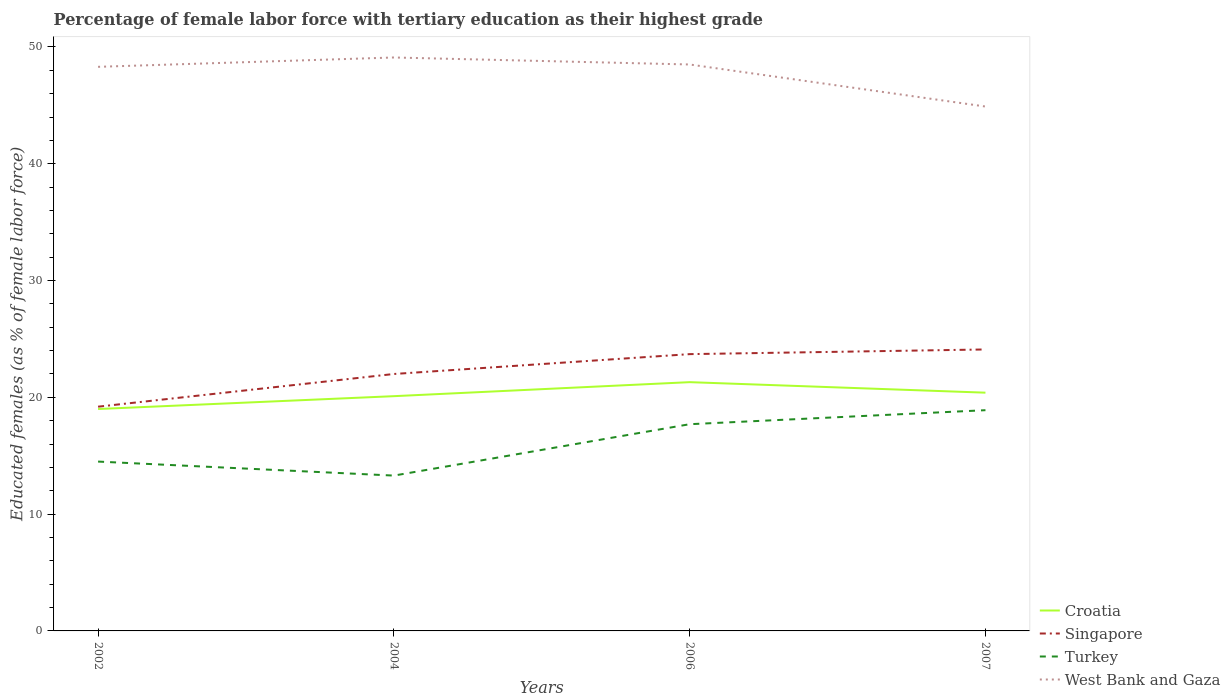Across all years, what is the maximum percentage of female labor force with tertiary education in Singapore?
Give a very brief answer. 19.2. What is the total percentage of female labor force with tertiary education in Croatia in the graph?
Offer a terse response. 0.9. What is the difference between the highest and the second highest percentage of female labor force with tertiary education in Turkey?
Offer a terse response. 5.6. What is the difference between the highest and the lowest percentage of female labor force with tertiary education in Turkey?
Provide a short and direct response. 2. Is the percentage of female labor force with tertiary education in Singapore strictly greater than the percentage of female labor force with tertiary education in West Bank and Gaza over the years?
Your response must be concise. Yes. How many lines are there?
Ensure brevity in your answer.  4. How many years are there in the graph?
Provide a succinct answer. 4. What is the difference between two consecutive major ticks on the Y-axis?
Your answer should be compact. 10. Are the values on the major ticks of Y-axis written in scientific E-notation?
Keep it short and to the point. No. Does the graph contain grids?
Offer a terse response. No. Where does the legend appear in the graph?
Keep it short and to the point. Bottom right. How many legend labels are there?
Ensure brevity in your answer.  4. How are the legend labels stacked?
Offer a very short reply. Vertical. What is the title of the graph?
Ensure brevity in your answer.  Percentage of female labor force with tertiary education as their highest grade. What is the label or title of the Y-axis?
Provide a short and direct response. Educated females (as % of female labor force). What is the Educated females (as % of female labor force) in Croatia in 2002?
Offer a terse response. 19. What is the Educated females (as % of female labor force) in Singapore in 2002?
Your answer should be very brief. 19.2. What is the Educated females (as % of female labor force) in Turkey in 2002?
Offer a terse response. 14.5. What is the Educated females (as % of female labor force) in West Bank and Gaza in 2002?
Your response must be concise. 48.3. What is the Educated females (as % of female labor force) in Croatia in 2004?
Keep it short and to the point. 20.1. What is the Educated females (as % of female labor force) of Turkey in 2004?
Make the answer very short. 13.3. What is the Educated females (as % of female labor force) in West Bank and Gaza in 2004?
Ensure brevity in your answer.  49.1. What is the Educated females (as % of female labor force) in Croatia in 2006?
Keep it short and to the point. 21.3. What is the Educated females (as % of female labor force) of Singapore in 2006?
Keep it short and to the point. 23.7. What is the Educated females (as % of female labor force) in Turkey in 2006?
Offer a terse response. 17.7. What is the Educated females (as % of female labor force) of West Bank and Gaza in 2006?
Provide a succinct answer. 48.5. What is the Educated females (as % of female labor force) of Croatia in 2007?
Provide a short and direct response. 20.4. What is the Educated females (as % of female labor force) in Singapore in 2007?
Offer a terse response. 24.1. What is the Educated females (as % of female labor force) of Turkey in 2007?
Offer a terse response. 18.9. What is the Educated females (as % of female labor force) in West Bank and Gaza in 2007?
Ensure brevity in your answer.  44.9. Across all years, what is the maximum Educated females (as % of female labor force) in Croatia?
Give a very brief answer. 21.3. Across all years, what is the maximum Educated females (as % of female labor force) of Singapore?
Make the answer very short. 24.1. Across all years, what is the maximum Educated females (as % of female labor force) of Turkey?
Make the answer very short. 18.9. Across all years, what is the maximum Educated females (as % of female labor force) of West Bank and Gaza?
Your response must be concise. 49.1. Across all years, what is the minimum Educated females (as % of female labor force) of Singapore?
Make the answer very short. 19.2. Across all years, what is the minimum Educated females (as % of female labor force) in Turkey?
Make the answer very short. 13.3. Across all years, what is the minimum Educated females (as % of female labor force) in West Bank and Gaza?
Keep it short and to the point. 44.9. What is the total Educated females (as % of female labor force) in Croatia in the graph?
Make the answer very short. 80.8. What is the total Educated females (as % of female labor force) of Singapore in the graph?
Give a very brief answer. 89. What is the total Educated females (as % of female labor force) in Turkey in the graph?
Provide a succinct answer. 64.4. What is the total Educated females (as % of female labor force) of West Bank and Gaza in the graph?
Your answer should be very brief. 190.8. What is the difference between the Educated females (as % of female labor force) in Singapore in 2002 and that in 2004?
Your answer should be very brief. -2.8. What is the difference between the Educated females (as % of female labor force) in West Bank and Gaza in 2002 and that in 2004?
Ensure brevity in your answer.  -0.8. What is the difference between the Educated females (as % of female labor force) of Croatia in 2002 and that in 2006?
Provide a succinct answer. -2.3. What is the difference between the Educated females (as % of female labor force) in Singapore in 2002 and that in 2006?
Your answer should be very brief. -4.5. What is the difference between the Educated females (as % of female labor force) of Turkey in 2002 and that in 2006?
Ensure brevity in your answer.  -3.2. What is the difference between the Educated females (as % of female labor force) of Singapore in 2002 and that in 2007?
Ensure brevity in your answer.  -4.9. What is the difference between the Educated females (as % of female labor force) of West Bank and Gaza in 2002 and that in 2007?
Offer a very short reply. 3.4. What is the difference between the Educated females (as % of female labor force) of Croatia in 2004 and that in 2006?
Your response must be concise. -1.2. What is the difference between the Educated females (as % of female labor force) in Singapore in 2004 and that in 2006?
Your answer should be compact. -1.7. What is the difference between the Educated females (as % of female labor force) in Turkey in 2004 and that in 2006?
Offer a terse response. -4.4. What is the difference between the Educated females (as % of female labor force) of West Bank and Gaza in 2004 and that in 2006?
Your answer should be very brief. 0.6. What is the difference between the Educated females (as % of female labor force) in Turkey in 2004 and that in 2007?
Your response must be concise. -5.6. What is the difference between the Educated females (as % of female labor force) in Turkey in 2006 and that in 2007?
Offer a terse response. -1.2. What is the difference between the Educated females (as % of female labor force) in Croatia in 2002 and the Educated females (as % of female labor force) in Singapore in 2004?
Give a very brief answer. -3. What is the difference between the Educated females (as % of female labor force) in Croatia in 2002 and the Educated females (as % of female labor force) in West Bank and Gaza in 2004?
Offer a very short reply. -30.1. What is the difference between the Educated females (as % of female labor force) of Singapore in 2002 and the Educated females (as % of female labor force) of Turkey in 2004?
Keep it short and to the point. 5.9. What is the difference between the Educated females (as % of female labor force) in Singapore in 2002 and the Educated females (as % of female labor force) in West Bank and Gaza in 2004?
Provide a short and direct response. -29.9. What is the difference between the Educated females (as % of female labor force) of Turkey in 2002 and the Educated females (as % of female labor force) of West Bank and Gaza in 2004?
Offer a terse response. -34.6. What is the difference between the Educated females (as % of female labor force) of Croatia in 2002 and the Educated females (as % of female labor force) of Singapore in 2006?
Give a very brief answer. -4.7. What is the difference between the Educated females (as % of female labor force) of Croatia in 2002 and the Educated females (as % of female labor force) of West Bank and Gaza in 2006?
Provide a short and direct response. -29.5. What is the difference between the Educated females (as % of female labor force) of Singapore in 2002 and the Educated females (as % of female labor force) of West Bank and Gaza in 2006?
Keep it short and to the point. -29.3. What is the difference between the Educated females (as % of female labor force) in Turkey in 2002 and the Educated females (as % of female labor force) in West Bank and Gaza in 2006?
Ensure brevity in your answer.  -34. What is the difference between the Educated females (as % of female labor force) in Croatia in 2002 and the Educated females (as % of female labor force) in Singapore in 2007?
Make the answer very short. -5.1. What is the difference between the Educated females (as % of female labor force) of Croatia in 2002 and the Educated females (as % of female labor force) of West Bank and Gaza in 2007?
Give a very brief answer. -25.9. What is the difference between the Educated females (as % of female labor force) of Singapore in 2002 and the Educated females (as % of female labor force) of West Bank and Gaza in 2007?
Ensure brevity in your answer.  -25.7. What is the difference between the Educated females (as % of female labor force) of Turkey in 2002 and the Educated females (as % of female labor force) of West Bank and Gaza in 2007?
Your answer should be very brief. -30.4. What is the difference between the Educated females (as % of female labor force) of Croatia in 2004 and the Educated females (as % of female labor force) of Singapore in 2006?
Your response must be concise. -3.6. What is the difference between the Educated females (as % of female labor force) in Croatia in 2004 and the Educated females (as % of female labor force) in Turkey in 2006?
Offer a terse response. 2.4. What is the difference between the Educated females (as % of female labor force) in Croatia in 2004 and the Educated females (as % of female labor force) in West Bank and Gaza in 2006?
Give a very brief answer. -28.4. What is the difference between the Educated females (as % of female labor force) of Singapore in 2004 and the Educated females (as % of female labor force) of West Bank and Gaza in 2006?
Provide a succinct answer. -26.5. What is the difference between the Educated females (as % of female labor force) of Turkey in 2004 and the Educated females (as % of female labor force) of West Bank and Gaza in 2006?
Offer a very short reply. -35.2. What is the difference between the Educated females (as % of female labor force) of Croatia in 2004 and the Educated females (as % of female labor force) of West Bank and Gaza in 2007?
Keep it short and to the point. -24.8. What is the difference between the Educated females (as % of female labor force) of Singapore in 2004 and the Educated females (as % of female labor force) of Turkey in 2007?
Make the answer very short. 3.1. What is the difference between the Educated females (as % of female labor force) in Singapore in 2004 and the Educated females (as % of female labor force) in West Bank and Gaza in 2007?
Ensure brevity in your answer.  -22.9. What is the difference between the Educated females (as % of female labor force) in Turkey in 2004 and the Educated females (as % of female labor force) in West Bank and Gaza in 2007?
Your answer should be compact. -31.6. What is the difference between the Educated females (as % of female labor force) in Croatia in 2006 and the Educated females (as % of female labor force) in West Bank and Gaza in 2007?
Make the answer very short. -23.6. What is the difference between the Educated females (as % of female labor force) in Singapore in 2006 and the Educated females (as % of female labor force) in Turkey in 2007?
Provide a short and direct response. 4.8. What is the difference between the Educated females (as % of female labor force) of Singapore in 2006 and the Educated females (as % of female labor force) of West Bank and Gaza in 2007?
Your answer should be compact. -21.2. What is the difference between the Educated females (as % of female labor force) in Turkey in 2006 and the Educated females (as % of female labor force) in West Bank and Gaza in 2007?
Keep it short and to the point. -27.2. What is the average Educated females (as % of female labor force) in Croatia per year?
Provide a succinct answer. 20.2. What is the average Educated females (as % of female labor force) in Singapore per year?
Make the answer very short. 22.25. What is the average Educated females (as % of female labor force) of West Bank and Gaza per year?
Offer a very short reply. 47.7. In the year 2002, what is the difference between the Educated females (as % of female labor force) in Croatia and Educated females (as % of female labor force) in Singapore?
Ensure brevity in your answer.  -0.2. In the year 2002, what is the difference between the Educated females (as % of female labor force) in Croatia and Educated females (as % of female labor force) in Turkey?
Give a very brief answer. 4.5. In the year 2002, what is the difference between the Educated females (as % of female labor force) in Croatia and Educated females (as % of female labor force) in West Bank and Gaza?
Your answer should be very brief. -29.3. In the year 2002, what is the difference between the Educated females (as % of female labor force) in Singapore and Educated females (as % of female labor force) in Turkey?
Your answer should be very brief. 4.7. In the year 2002, what is the difference between the Educated females (as % of female labor force) in Singapore and Educated females (as % of female labor force) in West Bank and Gaza?
Make the answer very short. -29.1. In the year 2002, what is the difference between the Educated females (as % of female labor force) in Turkey and Educated females (as % of female labor force) in West Bank and Gaza?
Provide a short and direct response. -33.8. In the year 2004, what is the difference between the Educated females (as % of female labor force) of Croatia and Educated females (as % of female labor force) of Singapore?
Keep it short and to the point. -1.9. In the year 2004, what is the difference between the Educated females (as % of female labor force) of Singapore and Educated females (as % of female labor force) of Turkey?
Provide a short and direct response. 8.7. In the year 2004, what is the difference between the Educated females (as % of female labor force) of Singapore and Educated females (as % of female labor force) of West Bank and Gaza?
Offer a terse response. -27.1. In the year 2004, what is the difference between the Educated females (as % of female labor force) in Turkey and Educated females (as % of female labor force) in West Bank and Gaza?
Give a very brief answer. -35.8. In the year 2006, what is the difference between the Educated females (as % of female labor force) of Croatia and Educated females (as % of female labor force) of Turkey?
Your answer should be compact. 3.6. In the year 2006, what is the difference between the Educated females (as % of female labor force) in Croatia and Educated females (as % of female labor force) in West Bank and Gaza?
Provide a succinct answer. -27.2. In the year 2006, what is the difference between the Educated females (as % of female labor force) in Singapore and Educated females (as % of female labor force) in Turkey?
Provide a succinct answer. 6. In the year 2006, what is the difference between the Educated females (as % of female labor force) in Singapore and Educated females (as % of female labor force) in West Bank and Gaza?
Ensure brevity in your answer.  -24.8. In the year 2006, what is the difference between the Educated females (as % of female labor force) of Turkey and Educated females (as % of female labor force) of West Bank and Gaza?
Offer a terse response. -30.8. In the year 2007, what is the difference between the Educated females (as % of female labor force) of Croatia and Educated females (as % of female labor force) of Singapore?
Make the answer very short. -3.7. In the year 2007, what is the difference between the Educated females (as % of female labor force) in Croatia and Educated females (as % of female labor force) in West Bank and Gaza?
Provide a succinct answer. -24.5. In the year 2007, what is the difference between the Educated females (as % of female labor force) in Singapore and Educated females (as % of female labor force) in Turkey?
Your answer should be very brief. 5.2. In the year 2007, what is the difference between the Educated females (as % of female labor force) of Singapore and Educated females (as % of female labor force) of West Bank and Gaza?
Provide a short and direct response. -20.8. In the year 2007, what is the difference between the Educated females (as % of female labor force) of Turkey and Educated females (as % of female labor force) of West Bank and Gaza?
Your answer should be very brief. -26. What is the ratio of the Educated females (as % of female labor force) in Croatia in 2002 to that in 2004?
Your response must be concise. 0.95. What is the ratio of the Educated females (as % of female labor force) of Singapore in 2002 to that in 2004?
Give a very brief answer. 0.87. What is the ratio of the Educated females (as % of female labor force) of Turkey in 2002 to that in 2004?
Provide a short and direct response. 1.09. What is the ratio of the Educated females (as % of female labor force) in West Bank and Gaza in 2002 to that in 2004?
Your response must be concise. 0.98. What is the ratio of the Educated females (as % of female labor force) of Croatia in 2002 to that in 2006?
Provide a succinct answer. 0.89. What is the ratio of the Educated females (as % of female labor force) of Singapore in 2002 to that in 2006?
Your answer should be compact. 0.81. What is the ratio of the Educated females (as % of female labor force) of Turkey in 2002 to that in 2006?
Provide a succinct answer. 0.82. What is the ratio of the Educated females (as % of female labor force) of West Bank and Gaza in 2002 to that in 2006?
Provide a succinct answer. 1. What is the ratio of the Educated females (as % of female labor force) of Croatia in 2002 to that in 2007?
Provide a short and direct response. 0.93. What is the ratio of the Educated females (as % of female labor force) in Singapore in 2002 to that in 2007?
Make the answer very short. 0.8. What is the ratio of the Educated females (as % of female labor force) in Turkey in 2002 to that in 2007?
Provide a short and direct response. 0.77. What is the ratio of the Educated females (as % of female labor force) of West Bank and Gaza in 2002 to that in 2007?
Your answer should be compact. 1.08. What is the ratio of the Educated females (as % of female labor force) in Croatia in 2004 to that in 2006?
Your answer should be very brief. 0.94. What is the ratio of the Educated females (as % of female labor force) in Singapore in 2004 to that in 2006?
Your response must be concise. 0.93. What is the ratio of the Educated females (as % of female labor force) of Turkey in 2004 to that in 2006?
Offer a terse response. 0.75. What is the ratio of the Educated females (as % of female labor force) of West Bank and Gaza in 2004 to that in 2006?
Keep it short and to the point. 1.01. What is the ratio of the Educated females (as % of female labor force) of Croatia in 2004 to that in 2007?
Provide a short and direct response. 0.99. What is the ratio of the Educated females (as % of female labor force) of Singapore in 2004 to that in 2007?
Your response must be concise. 0.91. What is the ratio of the Educated females (as % of female labor force) in Turkey in 2004 to that in 2007?
Ensure brevity in your answer.  0.7. What is the ratio of the Educated females (as % of female labor force) in West Bank and Gaza in 2004 to that in 2007?
Provide a succinct answer. 1.09. What is the ratio of the Educated females (as % of female labor force) of Croatia in 2006 to that in 2007?
Make the answer very short. 1.04. What is the ratio of the Educated females (as % of female labor force) of Singapore in 2006 to that in 2007?
Provide a succinct answer. 0.98. What is the ratio of the Educated females (as % of female labor force) of Turkey in 2006 to that in 2007?
Keep it short and to the point. 0.94. What is the ratio of the Educated females (as % of female labor force) in West Bank and Gaza in 2006 to that in 2007?
Ensure brevity in your answer.  1.08. What is the difference between the highest and the second highest Educated females (as % of female labor force) of Croatia?
Offer a terse response. 0.9. What is the difference between the highest and the second highest Educated females (as % of female labor force) of West Bank and Gaza?
Provide a short and direct response. 0.6. What is the difference between the highest and the lowest Educated females (as % of female labor force) in Croatia?
Offer a very short reply. 2.3. What is the difference between the highest and the lowest Educated females (as % of female labor force) in Turkey?
Give a very brief answer. 5.6. What is the difference between the highest and the lowest Educated females (as % of female labor force) of West Bank and Gaza?
Keep it short and to the point. 4.2. 